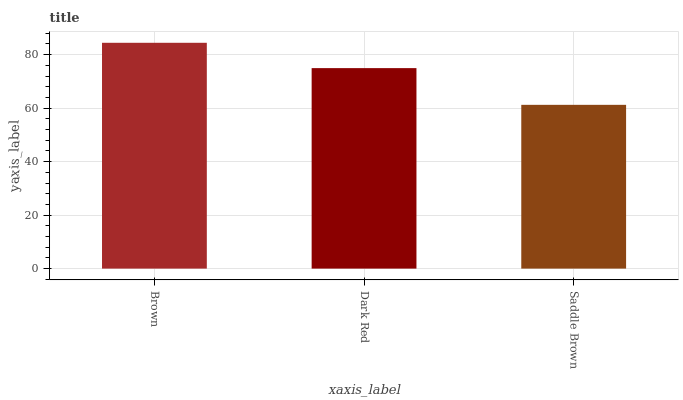Is Saddle Brown the minimum?
Answer yes or no. Yes. Is Brown the maximum?
Answer yes or no. Yes. Is Dark Red the minimum?
Answer yes or no. No. Is Dark Red the maximum?
Answer yes or no. No. Is Brown greater than Dark Red?
Answer yes or no. Yes. Is Dark Red less than Brown?
Answer yes or no. Yes. Is Dark Red greater than Brown?
Answer yes or no. No. Is Brown less than Dark Red?
Answer yes or no. No. Is Dark Red the high median?
Answer yes or no. Yes. Is Dark Red the low median?
Answer yes or no. Yes. Is Brown the high median?
Answer yes or no. No. Is Brown the low median?
Answer yes or no. No. 